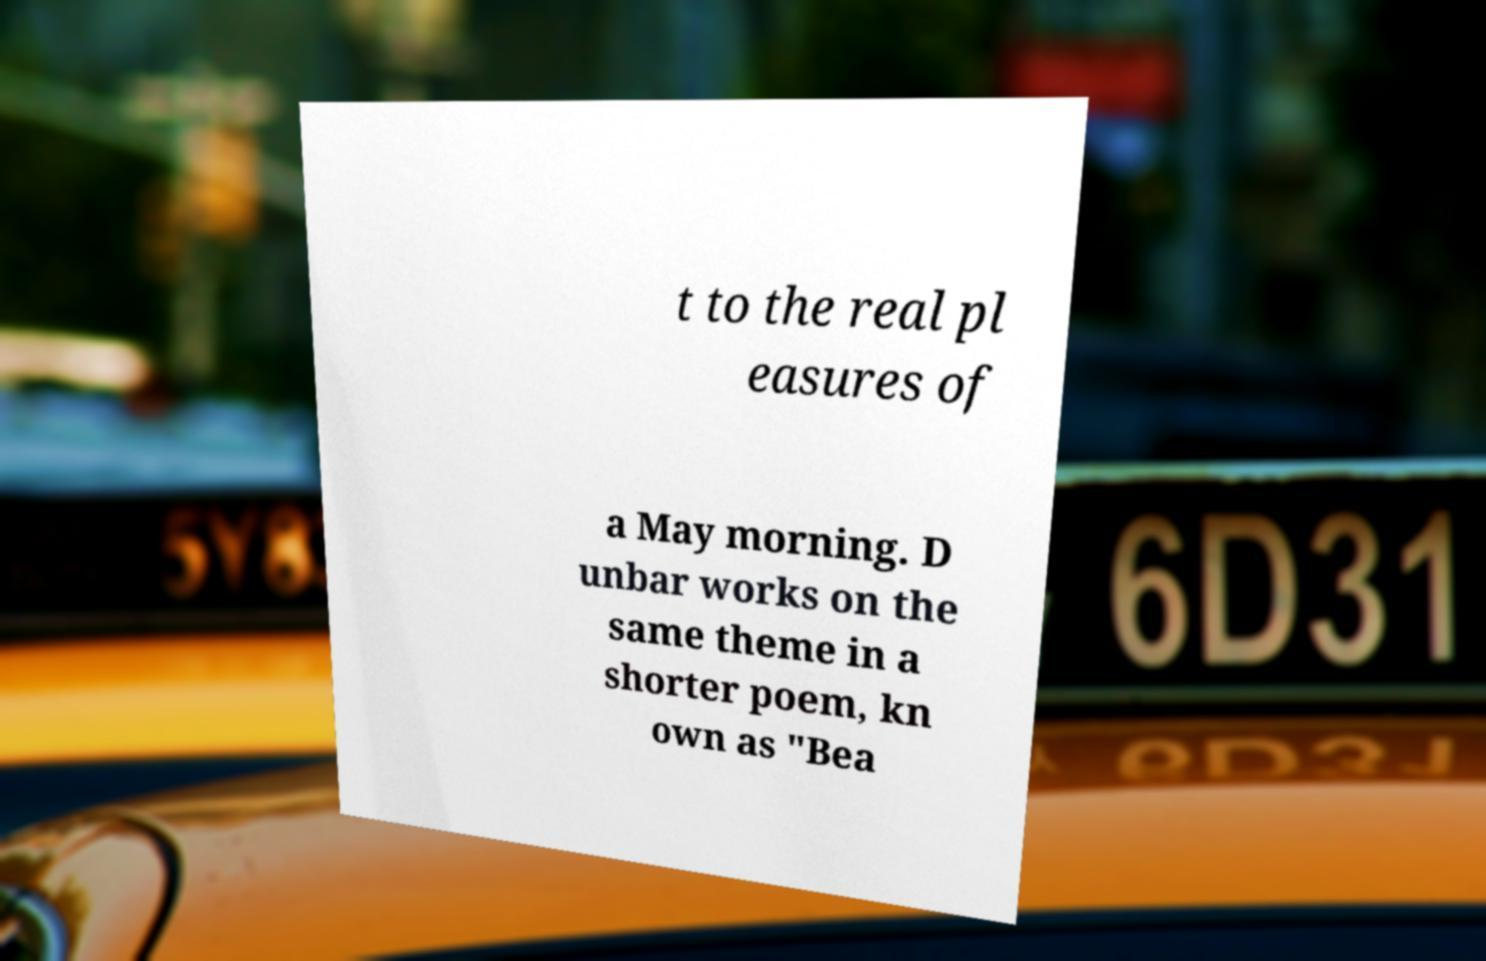For documentation purposes, I need the text within this image transcribed. Could you provide that? t to the real pl easures of a May morning. D unbar works on the same theme in a shorter poem, kn own as "Bea 